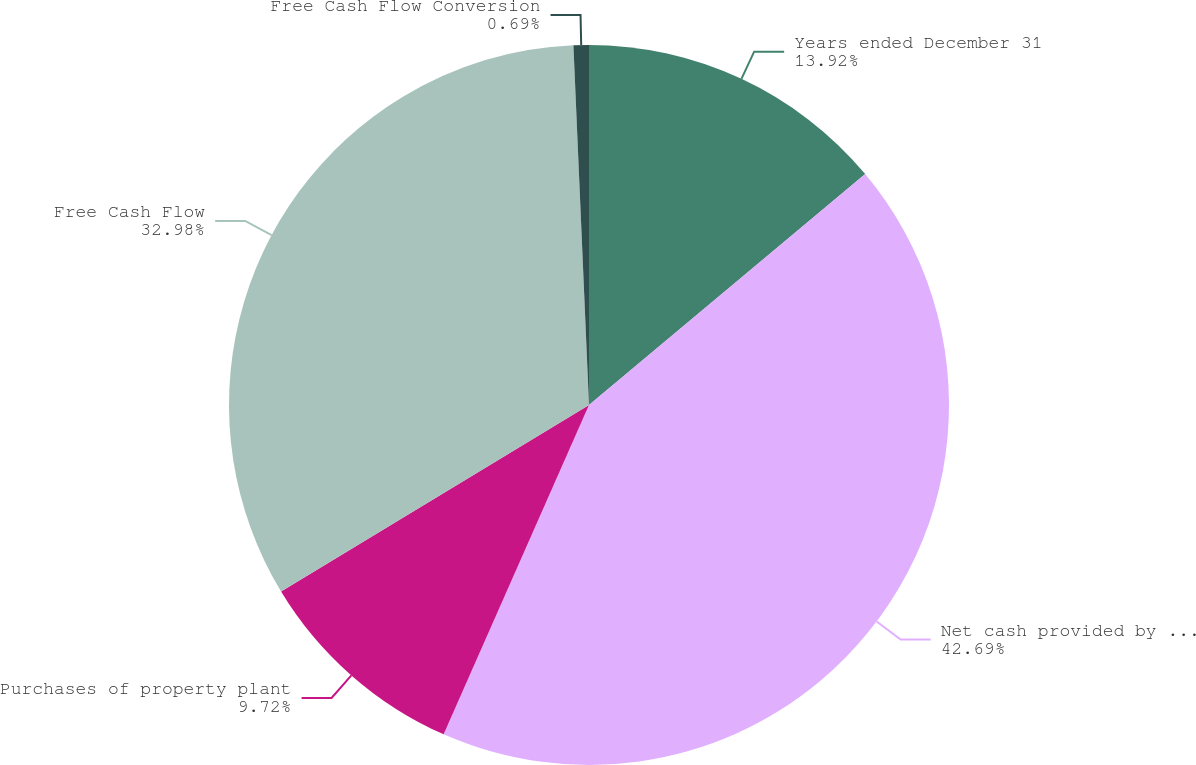Convert chart to OTSL. <chart><loc_0><loc_0><loc_500><loc_500><pie_chart><fcel>Years ended December 31<fcel>Net cash provided by operating<fcel>Purchases of property plant<fcel>Free Cash Flow<fcel>Free Cash Flow Conversion<nl><fcel>13.92%<fcel>42.7%<fcel>9.72%<fcel>32.98%<fcel>0.69%<nl></chart> 